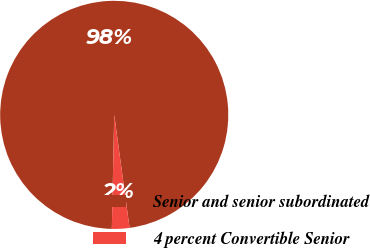<chart> <loc_0><loc_0><loc_500><loc_500><pie_chart><fcel>Senior and senior subordinated<fcel>4 percent Convertible Senior<nl><fcel>97.52%<fcel>2.48%<nl></chart> 